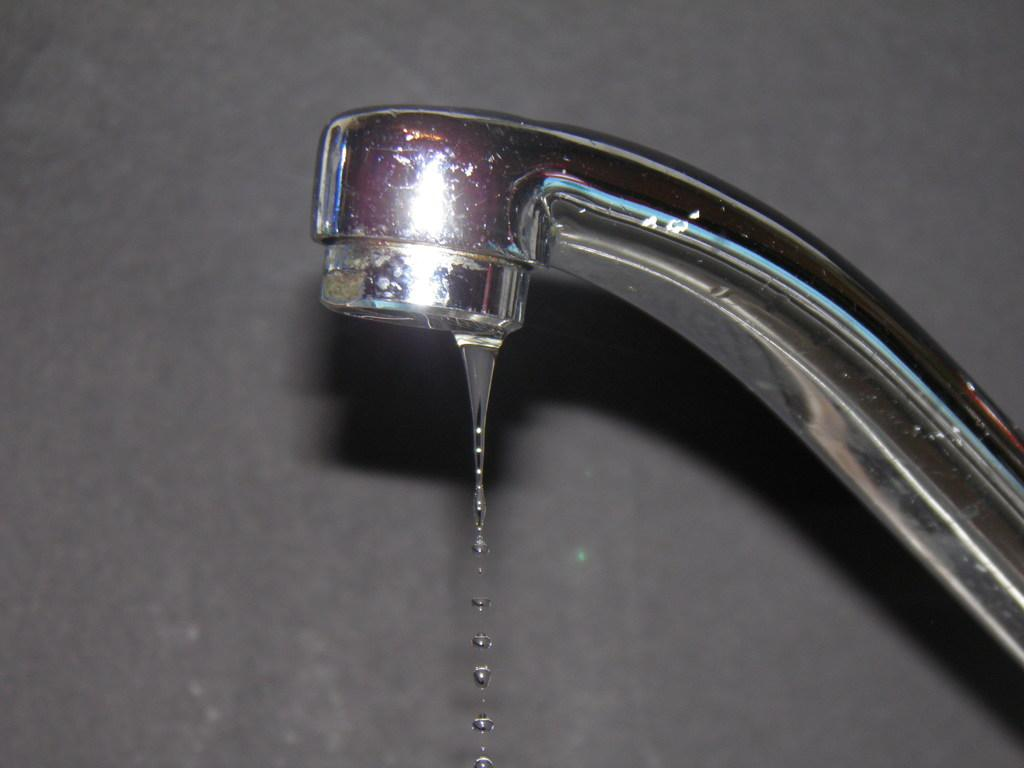What can be seen on the right side of the image? There is a tap on the right side of the image. What is visible in the background of the image? There is a wall in the background of the image. How many books are stacked on the pan in the image? There are no books or pans present in the image. 